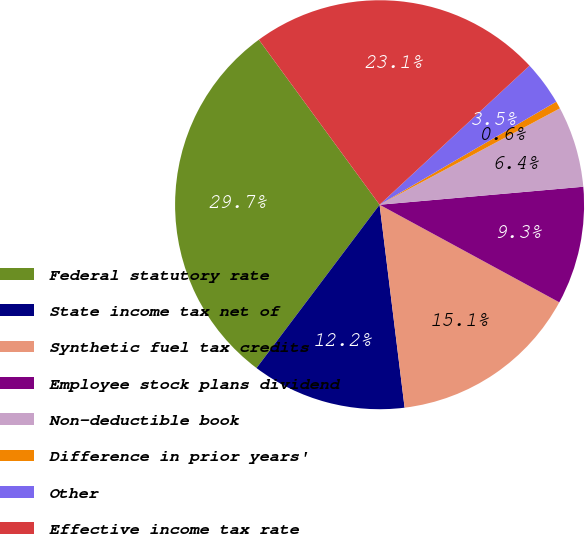Convert chart. <chart><loc_0><loc_0><loc_500><loc_500><pie_chart><fcel>Federal statutory rate<fcel>State income tax net of<fcel>Synthetic fuel tax credits<fcel>Employee stock plans dividend<fcel>Non-deductible book<fcel>Difference in prior years'<fcel>Other<fcel>Effective income tax rate<nl><fcel>29.67%<fcel>12.23%<fcel>15.13%<fcel>9.32%<fcel>6.41%<fcel>0.59%<fcel>3.5%<fcel>23.15%<nl></chart> 